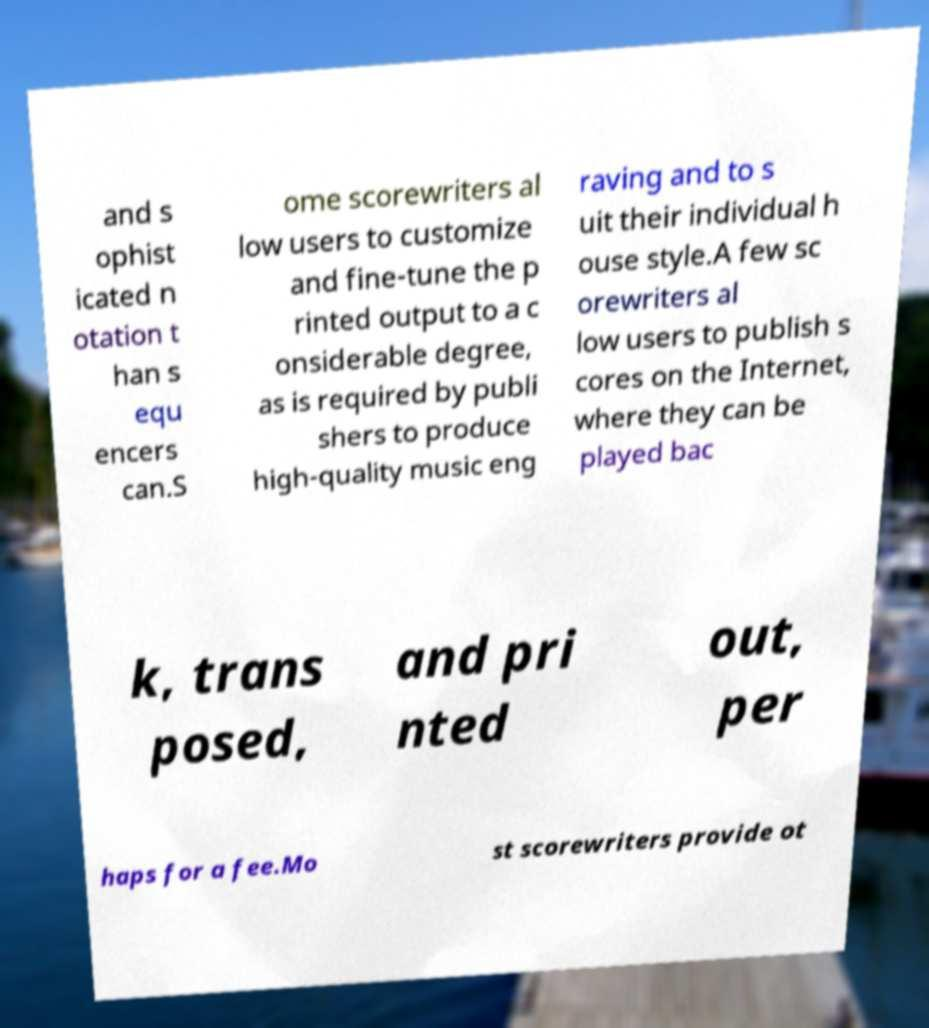What messages or text are displayed in this image? I need them in a readable, typed format. and s ophist icated n otation t han s equ encers can.S ome scorewriters al low users to customize and fine-tune the p rinted output to a c onsiderable degree, as is required by publi shers to produce high-quality music eng raving and to s uit their individual h ouse style.A few sc orewriters al low users to publish s cores on the Internet, where they can be played bac k, trans posed, and pri nted out, per haps for a fee.Mo st scorewriters provide ot 